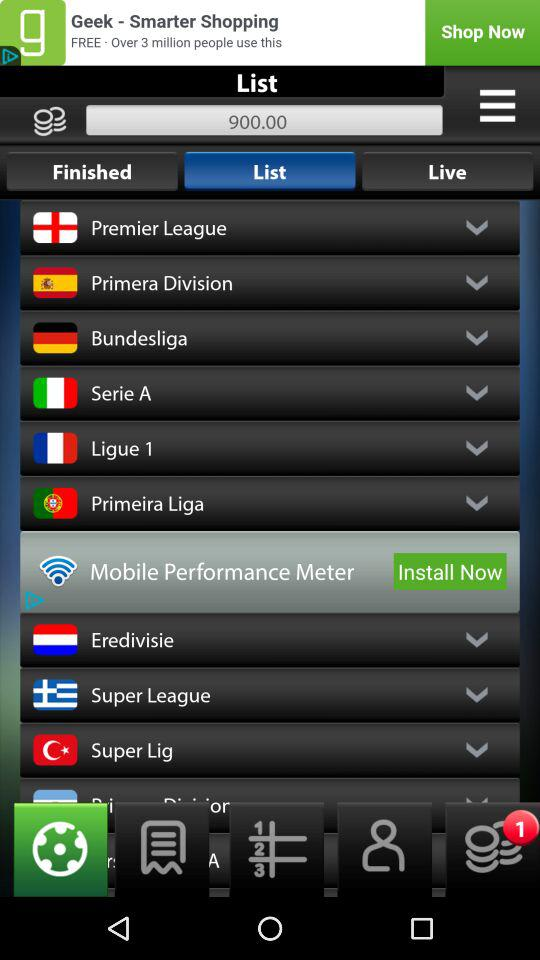Which Tab is selected? The selected tab is "List". 